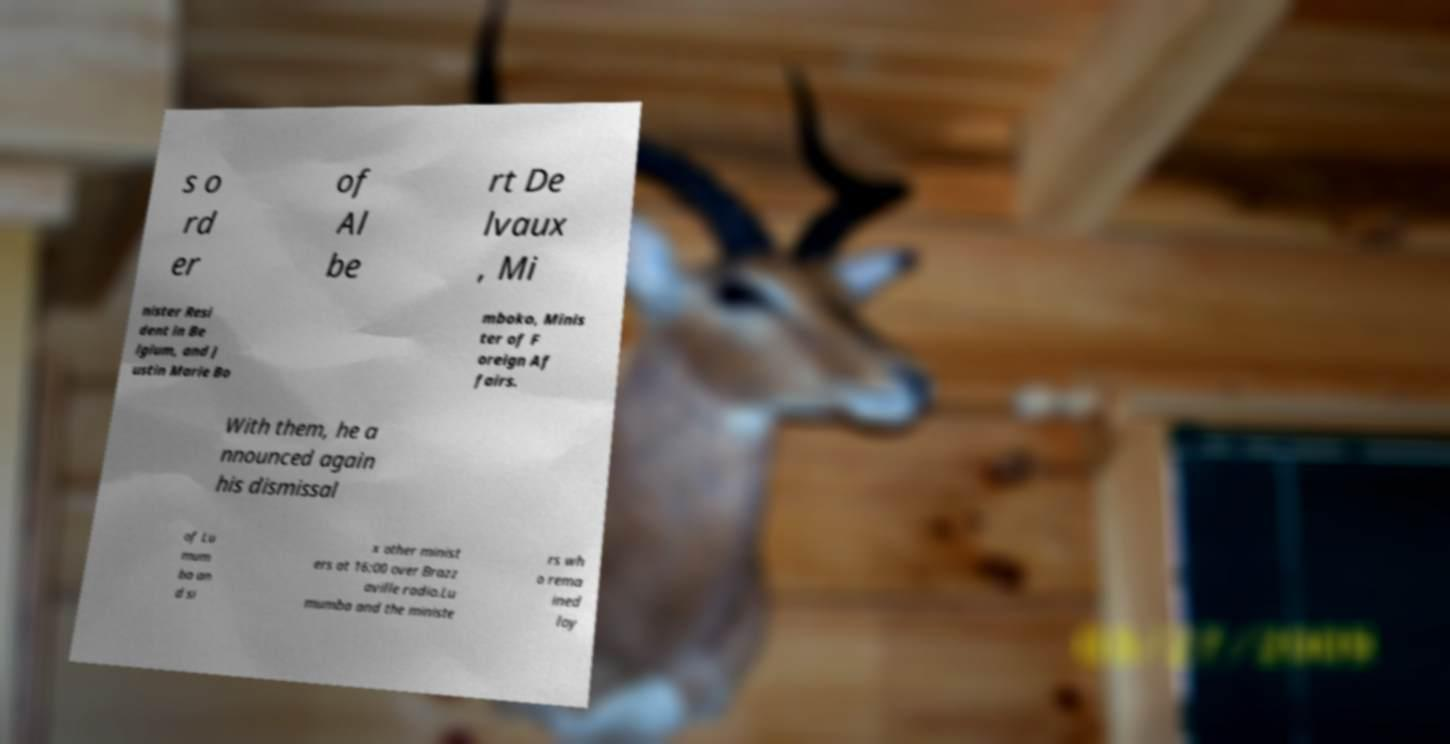Please identify and transcribe the text found in this image. s o rd er of Al be rt De lvaux , Mi nister Resi dent in Be lgium, and J ustin Marie Bo mboko, Minis ter of F oreign Af fairs. With them, he a nnounced again his dismissal of Lu mum ba an d si x other minist ers at 16:00 over Brazz aville radio.Lu mumba and the ministe rs wh o rema ined loy 